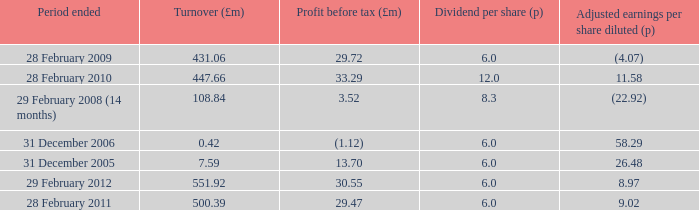What was the turnover when the profit before tax was 29.47? 500.39. 